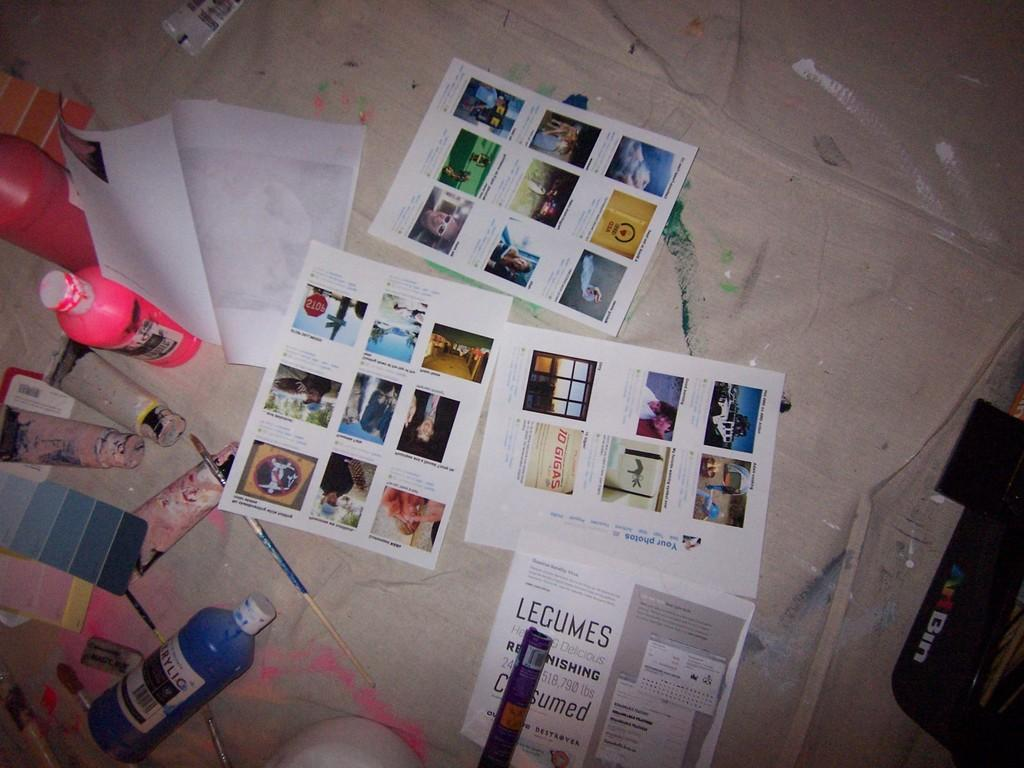<image>
Provide a brief description of the given image. a series of pages one of which says Legumes on it 